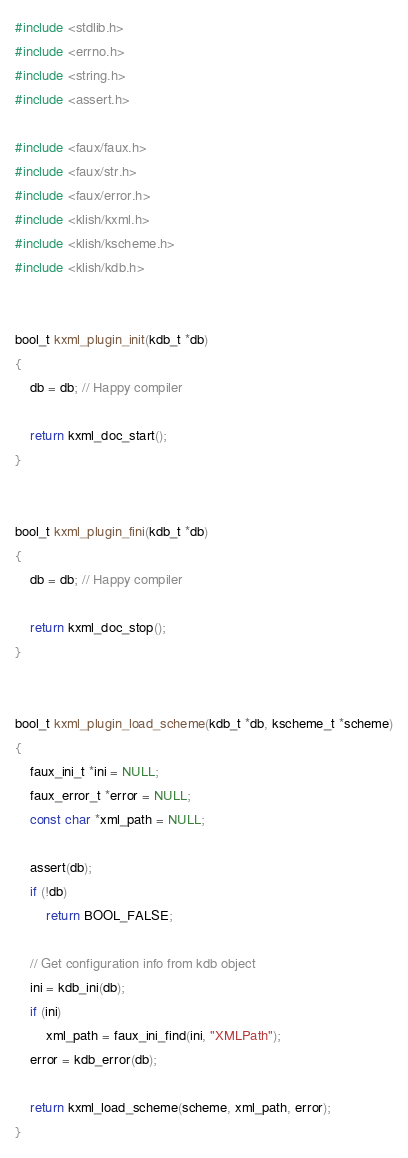Convert code to text. <code><loc_0><loc_0><loc_500><loc_500><_C_>#include <stdlib.h>
#include <errno.h>
#include <string.h>
#include <assert.h>

#include <faux/faux.h>
#include <faux/str.h>
#include <faux/error.h>
#include <klish/kxml.h>
#include <klish/kscheme.h>
#include <klish/kdb.h>


bool_t kxml_plugin_init(kdb_t *db)
{
	db = db; // Happy compiler

	return kxml_doc_start();
}


bool_t kxml_plugin_fini(kdb_t *db)
{
	db = db; // Happy compiler

	return kxml_doc_stop();
}


bool_t kxml_plugin_load_scheme(kdb_t *db, kscheme_t *scheme)
{
	faux_ini_t *ini = NULL;
	faux_error_t *error = NULL;
	const char *xml_path = NULL;

	assert(db);
	if (!db)
		return BOOL_FALSE;

	// Get configuration info from kdb object
	ini = kdb_ini(db);
	if (ini)
		xml_path = faux_ini_find(ini, "XMLPath");
	error = kdb_error(db);

	return kxml_load_scheme(scheme, xml_path, error);
}
</code> 